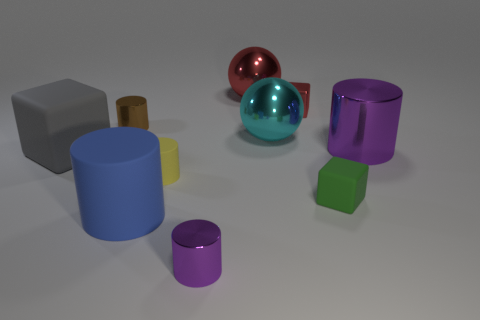Does the small matte object to the right of the large red thing have the same color as the tiny cylinder behind the large gray matte cube?
Provide a short and direct response. No. How many matte things are either big blue cylinders or yellow cylinders?
Provide a succinct answer. 2. Is there anything else that is the same size as the cyan thing?
Provide a short and direct response. Yes. What is the shape of the rubber thing to the right of the tiny metal cylinder that is in front of the small matte cylinder?
Keep it short and to the point. Cube. Is the cube that is left of the tiny red shiny object made of the same material as the small block that is behind the brown cylinder?
Provide a succinct answer. No. How many small brown cylinders are behind the blue thing that is in front of the gray cube?
Offer a terse response. 1. There is a purple thing behind the big gray rubber block; does it have the same shape as the rubber thing that is behind the yellow thing?
Offer a terse response. No. What is the size of the cylinder that is on the right side of the yellow thing and in front of the small green block?
Your answer should be compact. Small. There is another big shiny object that is the same shape as the big cyan shiny thing; what color is it?
Provide a succinct answer. Red. What is the color of the big metal object that is behind the small metallic cylinder behind the gray cube?
Your answer should be very brief. Red. 